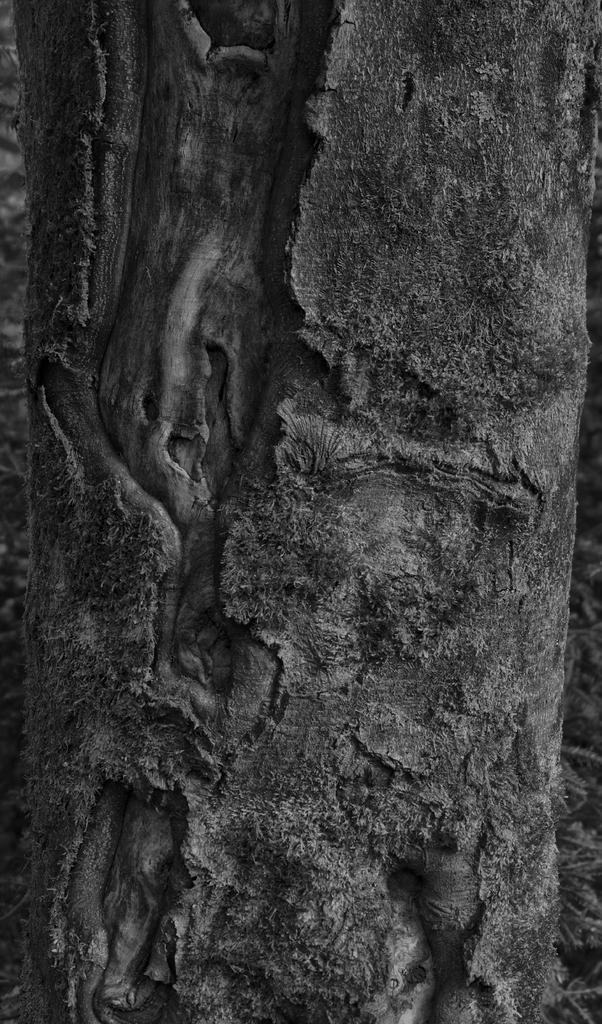What is the color scheme of the image? The image is black and white. What can be seen in the image besides the color scheme? There is a bark of a tree in the image. Where is the playground located in the image? There is no playground present in the image; it only features the bark of a tree. What type of cable can be seen hanging from the tree in the image? There is no cable visible in the image; it only features the bark of a tree. 